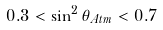Convert formula to latex. <formula><loc_0><loc_0><loc_500><loc_500>0 . 3 < \sin ^ { 2 } \theta _ { A t m } < 0 . 7</formula> 